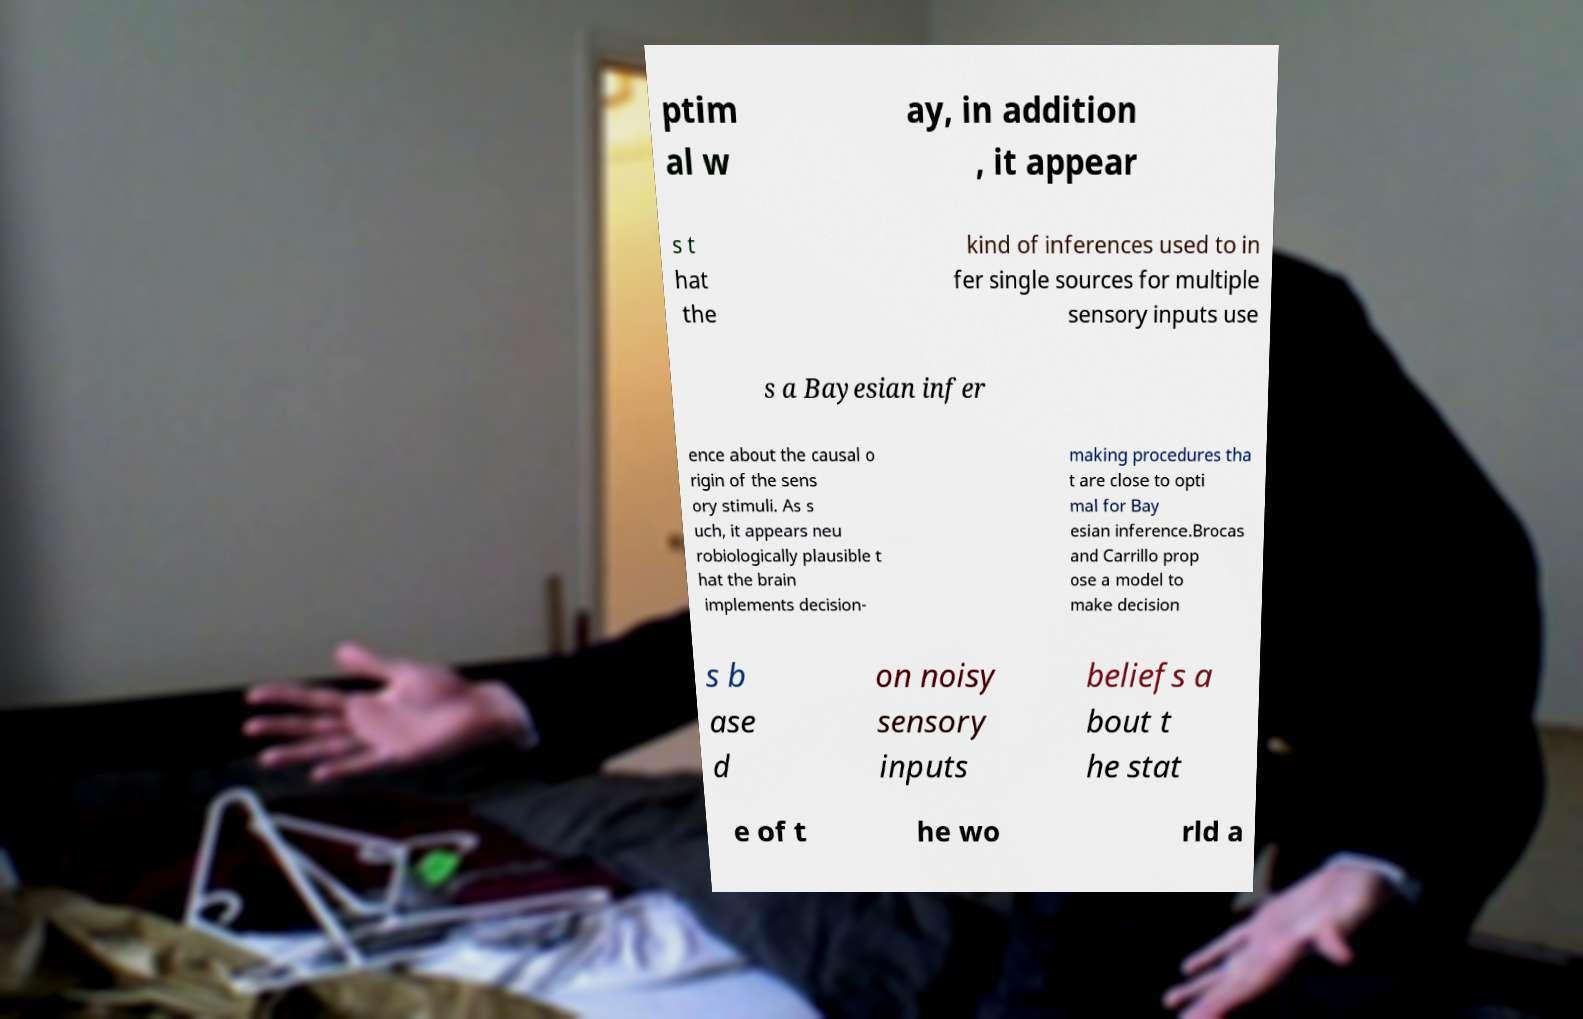What messages or text are displayed in this image? I need them in a readable, typed format. ptim al w ay, in addition , it appear s t hat the kind of inferences used to in fer single sources for multiple sensory inputs use s a Bayesian infer ence about the causal o rigin of the sens ory stimuli. As s uch, it appears neu robiologically plausible t hat the brain implements decision- making procedures tha t are close to opti mal for Bay esian inference.Brocas and Carrillo prop ose a model to make decision s b ase d on noisy sensory inputs beliefs a bout t he stat e of t he wo rld a 